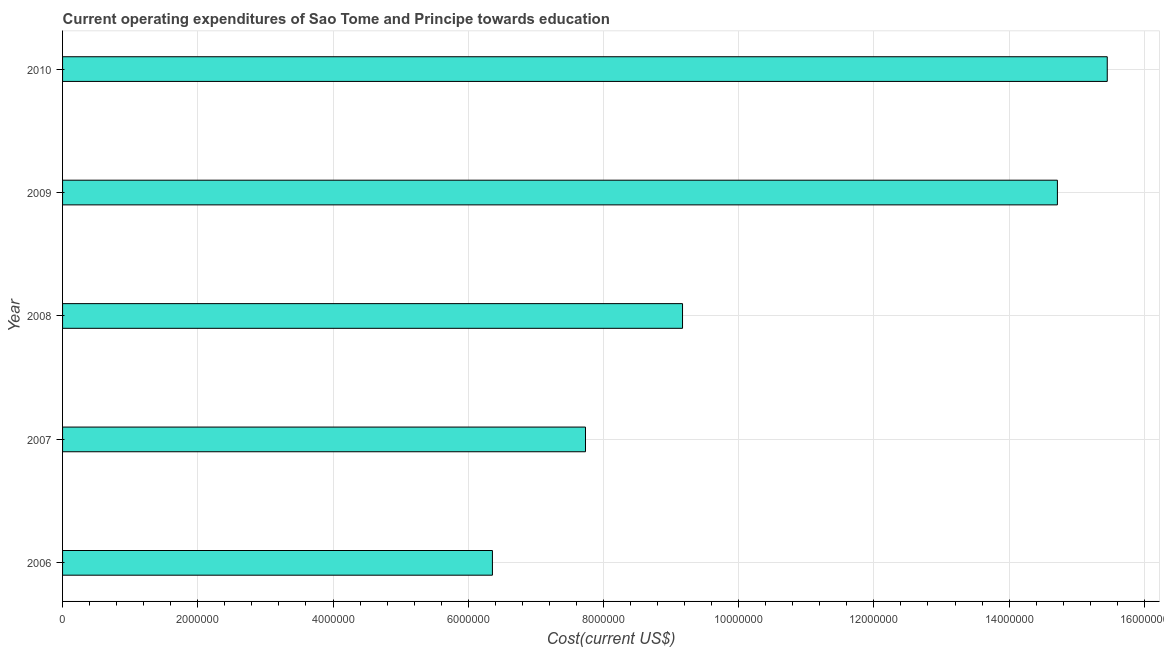Does the graph contain grids?
Offer a terse response. Yes. What is the title of the graph?
Offer a very short reply. Current operating expenditures of Sao Tome and Principe towards education. What is the label or title of the X-axis?
Provide a short and direct response. Cost(current US$). What is the education expenditure in 2010?
Give a very brief answer. 1.55e+07. Across all years, what is the maximum education expenditure?
Your answer should be very brief. 1.55e+07. Across all years, what is the minimum education expenditure?
Offer a very short reply. 6.36e+06. In which year was the education expenditure maximum?
Your response must be concise. 2010. What is the sum of the education expenditure?
Your answer should be very brief. 5.34e+07. What is the difference between the education expenditure in 2008 and 2009?
Ensure brevity in your answer.  -5.54e+06. What is the average education expenditure per year?
Make the answer very short. 1.07e+07. What is the median education expenditure?
Your answer should be very brief. 9.17e+06. What is the ratio of the education expenditure in 2006 to that in 2008?
Make the answer very short. 0.69. What is the difference between the highest and the second highest education expenditure?
Make the answer very short. 7.37e+05. Is the sum of the education expenditure in 2009 and 2010 greater than the maximum education expenditure across all years?
Provide a succinct answer. Yes. What is the difference between the highest and the lowest education expenditure?
Provide a succinct answer. 9.09e+06. How many bars are there?
Offer a terse response. 5. How many years are there in the graph?
Your answer should be compact. 5. What is the Cost(current US$) of 2006?
Make the answer very short. 6.36e+06. What is the Cost(current US$) in 2007?
Give a very brief answer. 7.73e+06. What is the Cost(current US$) in 2008?
Your answer should be compact. 9.17e+06. What is the Cost(current US$) in 2009?
Your response must be concise. 1.47e+07. What is the Cost(current US$) in 2010?
Give a very brief answer. 1.55e+07. What is the difference between the Cost(current US$) in 2006 and 2007?
Your answer should be compact. -1.38e+06. What is the difference between the Cost(current US$) in 2006 and 2008?
Give a very brief answer. -2.81e+06. What is the difference between the Cost(current US$) in 2006 and 2009?
Keep it short and to the point. -8.36e+06. What is the difference between the Cost(current US$) in 2006 and 2010?
Give a very brief answer. -9.09e+06. What is the difference between the Cost(current US$) in 2007 and 2008?
Give a very brief answer. -1.44e+06. What is the difference between the Cost(current US$) in 2007 and 2009?
Give a very brief answer. -6.98e+06. What is the difference between the Cost(current US$) in 2007 and 2010?
Your answer should be very brief. -7.72e+06. What is the difference between the Cost(current US$) in 2008 and 2009?
Your answer should be very brief. -5.54e+06. What is the difference between the Cost(current US$) in 2008 and 2010?
Your answer should be compact. -6.28e+06. What is the difference between the Cost(current US$) in 2009 and 2010?
Provide a short and direct response. -7.37e+05. What is the ratio of the Cost(current US$) in 2006 to that in 2007?
Provide a short and direct response. 0.82. What is the ratio of the Cost(current US$) in 2006 to that in 2008?
Ensure brevity in your answer.  0.69. What is the ratio of the Cost(current US$) in 2006 to that in 2009?
Ensure brevity in your answer.  0.43. What is the ratio of the Cost(current US$) in 2006 to that in 2010?
Offer a terse response. 0.41. What is the ratio of the Cost(current US$) in 2007 to that in 2008?
Make the answer very short. 0.84. What is the ratio of the Cost(current US$) in 2007 to that in 2009?
Make the answer very short. 0.53. What is the ratio of the Cost(current US$) in 2007 to that in 2010?
Keep it short and to the point. 0.5. What is the ratio of the Cost(current US$) in 2008 to that in 2009?
Provide a succinct answer. 0.62. What is the ratio of the Cost(current US$) in 2008 to that in 2010?
Provide a succinct answer. 0.59. 